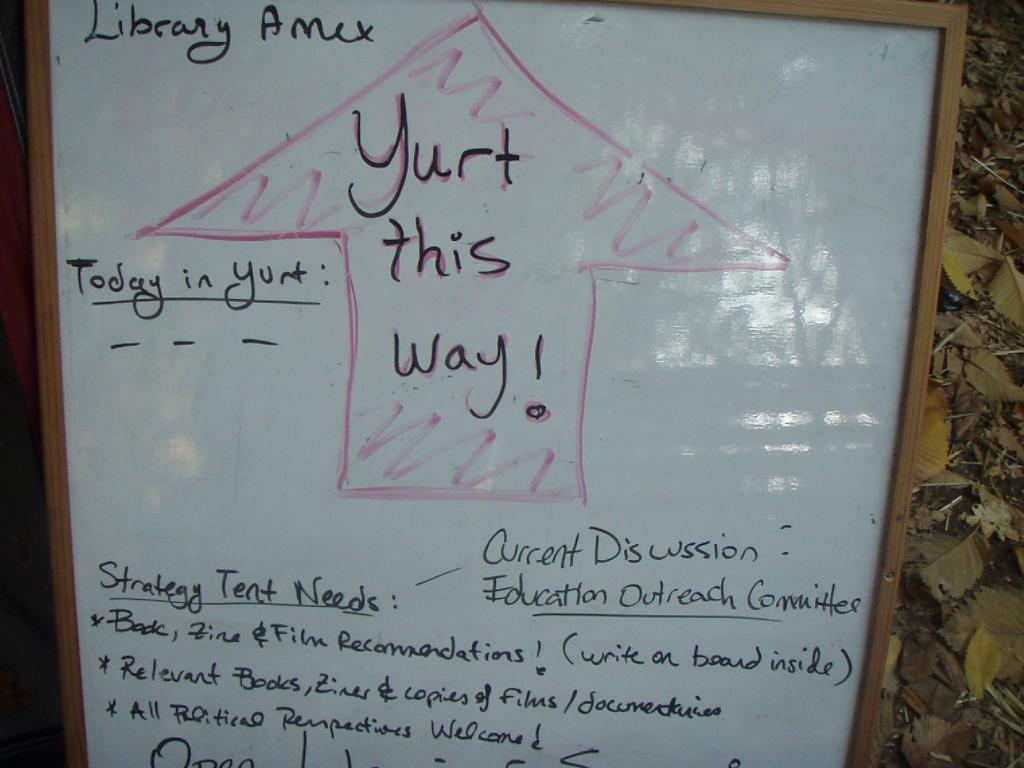Provide a one-sentence caption for the provided image. The dry erase board has a lot of writing on it along with an arrow pointing up with the words, "Yurt this way!". 